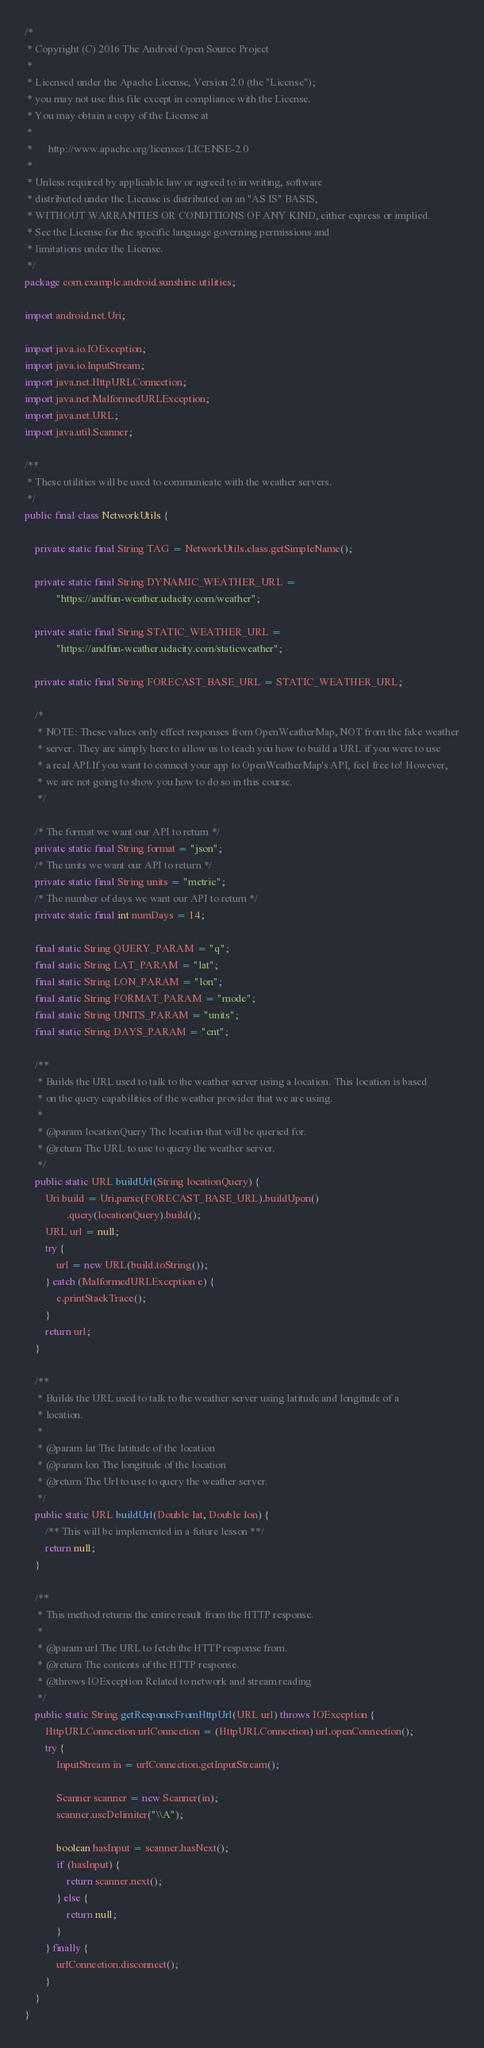Convert code to text. <code><loc_0><loc_0><loc_500><loc_500><_Java_>/*
 * Copyright (C) 2016 The Android Open Source Project
 *
 * Licensed under the Apache License, Version 2.0 (the "License");
 * you may not use this file except in compliance with the License.
 * You may obtain a copy of the License at
 *
 *      http://www.apache.org/licenses/LICENSE-2.0
 *
 * Unless required by applicable law or agreed to in writing, software
 * distributed under the License is distributed on an "AS IS" BASIS,
 * WITHOUT WARRANTIES OR CONDITIONS OF ANY KIND, either express or implied.
 * See the License for the specific language governing permissions and
 * limitations under the License.
 */
package com.example.android.sunshine.utilities;

import android.net.Uri;

import java.io.IOException;
import java.io.InputStream;
import java.net.HttpURLConnection;
import java.net.MalformedURLException;
import java.net.URL;
import java.util.Scanner;

/**
 * These utilities will be used to communicate with the weather servers.
 */
public final class NetworkUtils {

    private static final String TAG = NetworkUtils.class.getSimpleName();

    private static final String DYNAMIC_WEATHER_URL =
            "https://andfun-weather.udacity.com/weather";

    private static final String STATIC_WEATHER_URL =
            "https://andfun-weather.udacity.com/staticweather";

    private static final String FORECAST_BASE_URL = STATIC_WEATHER_URL;

    /*
     * NOTE: These values only effect responses from OpenWeatherMap, NOT from the fake weather
     * server. They are simply here to allow us to teach you how to build a URL if you were to use
     * a real API.If you want to connect your app to OpenWeatherMap's API, feel free to! However,
     * we are not going to show you how to do so in this course.
     */

    /* The format we want our API to return */
    private static final String format = "json";
    /* The units we want our API to return */
    private static final String units = "metric";
    /* The number of days we want our API to return */
    private static final int numDays = 14;

    final static String QUERY_PARAM = "q";
    final static String LAT_PARAM = "lat";
    final static String LON_PARAM = "lon";
    final static String FORMAT_PARAM = "mode";
    final static String UNITS_PARAM = "units";
    final static String DAYS_PARAM = "cnt";

    /**
     * Builds the URL used to talk to the weather server using a location. This location is based
     * on the query capabilities of the weather provider that we are using.
     *
     * @param locationQuery The location that will be queried for.
     * @return The URL to use to query the weather server.
     */
    public static URL buildUrl(String locationQuery) {
        Uri build = Uri.parse(FORECAST_BASE_URL).buildUpon()
                .query(locationQuery).build();
        URL url = null;
        try {
            url = new URL(build.toString());
        } catch (MalformedURLException e) {
            e.printStackTrace();
        }
        return url;
    }

    /**
     * Builds the URL used to talk to the weather server using latitude and longitude of a
     * location.
     *
     * @param lat The latitude of the location
     * @param lon The longitude of the location
     * @return The Url to use to query the weather server.
     */
    public static URL buildUrl(Double lat, Double lon) {
        /** This will be implemented in a future lesson **/
        return null;
    }

    /**
     * This method returns the entire result from the HTTP response.
     *
     * @param url The URL to fetch the HTTP response from.
     * @return The contents of the HTTP response.
     * @throws IOException Related to network and stream reading
     */
    public static String getResponseFromHttpUrl(URL url) throws IOException {
        HttpURLConnection urlConnection = (HttpURLConnection) url.openConnection();
        try {
            InputStream in = urlConnection.getInputStream();

            Scanner scanner = new Scanner(in);
            scanner.useDelimiter("\\A");

            boolean hasInput = scanner.hasNext();
            if (hasInput) {
                return scanner.next();
            } else {
                return null;
            }
        } finally {
            urlConnection.disconnect();
        }
    }
}</code> 